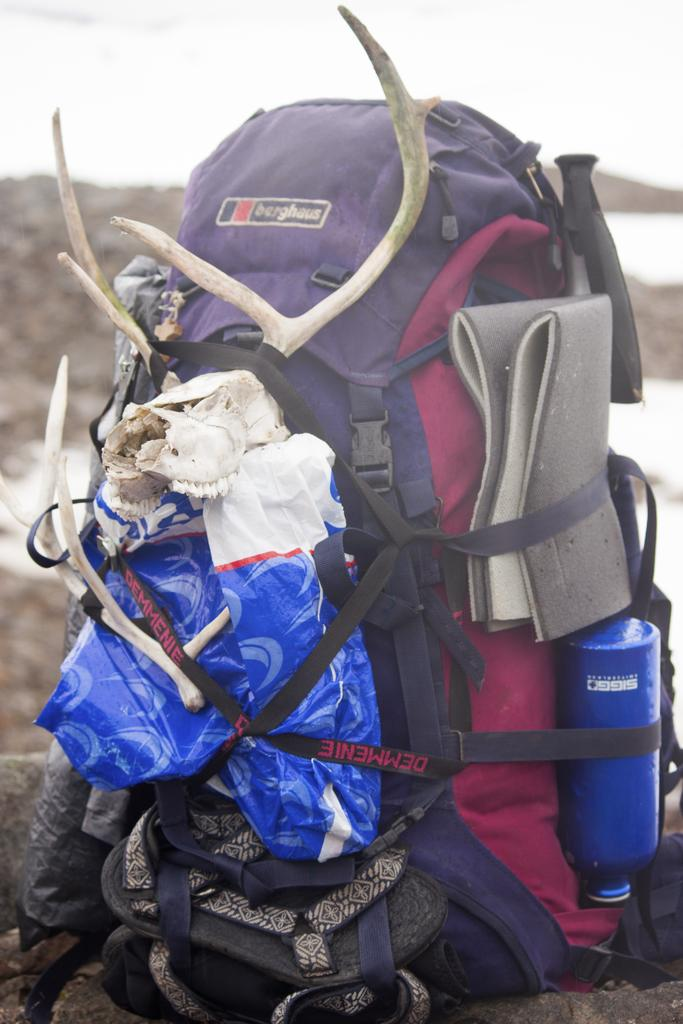What is the main object in the image? The image shows a luggage bag. What is attached to the luggage bag? There is a skeleton attached to the luggage bag. What else can be seen on the luggage bag? Footwear is present on the luggage bag. Is there any other item tied to the luggage bag? Yes, a water bottle is tied to the luggage bag. What type of skirt is the brother wearing in the image? There is no brother or skirt present in the image; it only features a luggage bag with a skeleton, footwear, and a water bottle. 